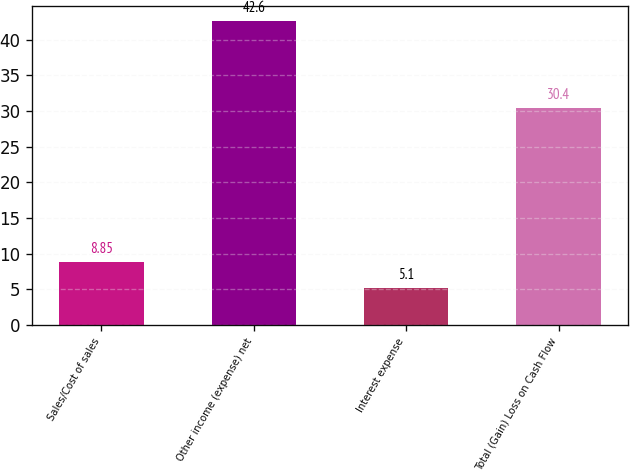Convert chart to OTSL. <chart><loc_0><loc_0><loc_500><loc_500><bar_chart><fcel>Sales/Cost of sales<fcel>Other income (expense) net<fcel>Interest expense<fcel>Total (Gain) Loss on Cash Flow<nl><fcel>8.85<fcel>42.6<fcel>5.1<fcel>30.4<nl></chart> 